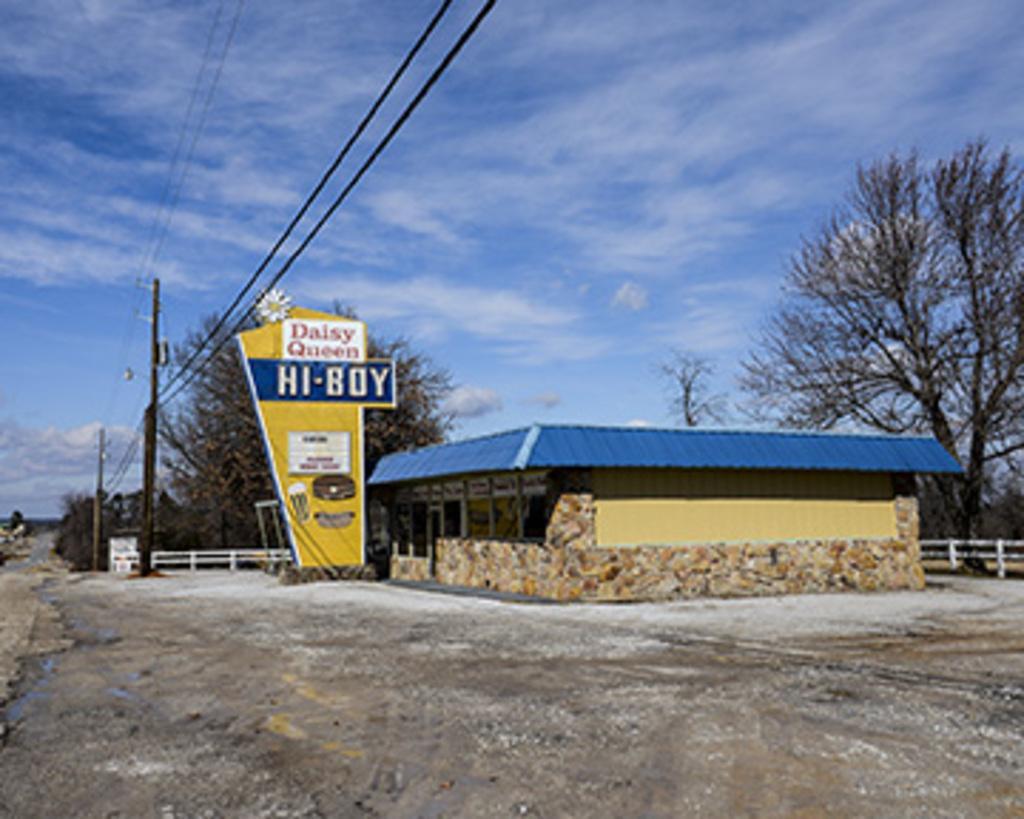In one or two sentences, can you explain what this image depicts? Here we can see poles, trees, hoarding, house, and a fence. In the background there is sky with clouds. 